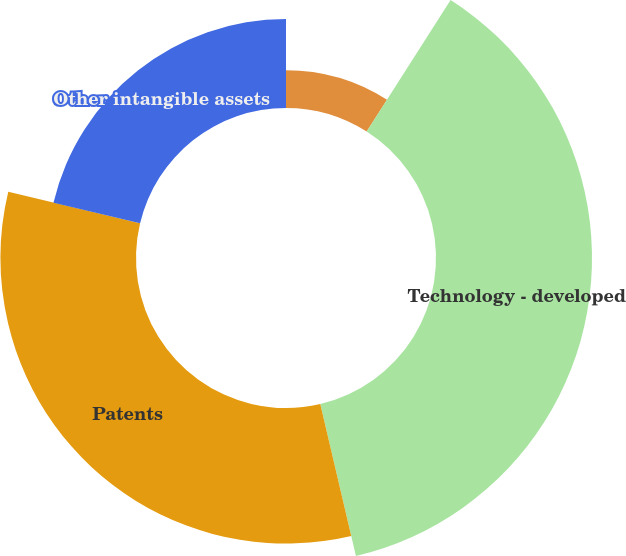<chart> <loc_0><loc_0><loc_500><loc_500><pie_chart><fcel>Technology - core<fcel>Technology - developed<fcel>Patents<fcel>Other intangible assets<nl><fcel>9.04%<fcel>37.29%<fcel>32.39%<fcel>21.28%<nl></chart> 